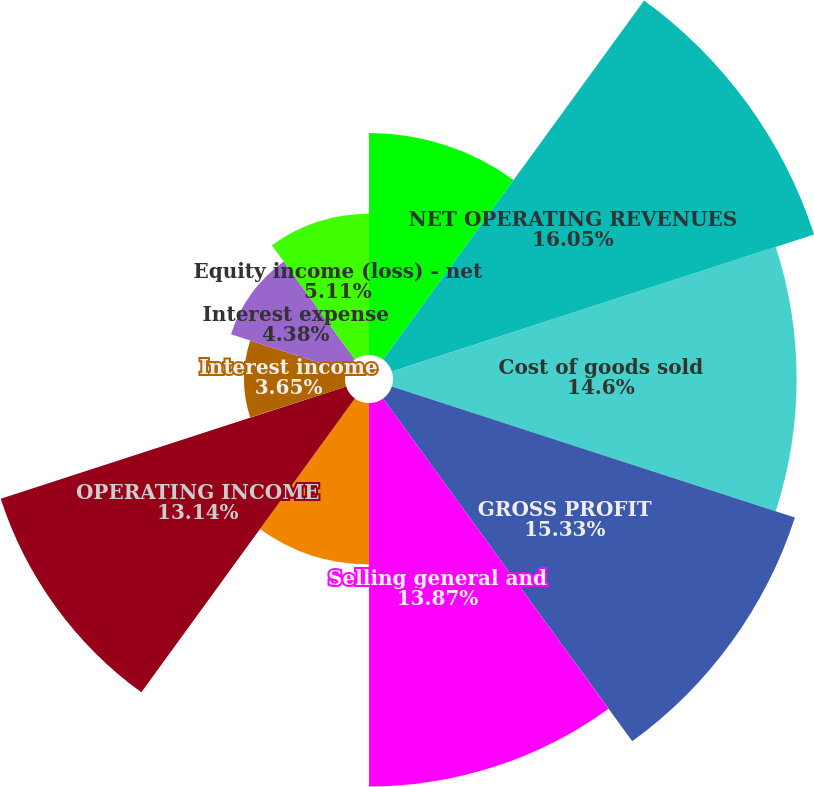Convert chart to OTSL. <chart><loc_0><loc_0><loc_500><loc_500><pie_chart><fcel>Year Ended December 31<fcel>NET OPERATING REVENUES<fcel>Cost of goods sold<fcel>GROSS PROFIT<fcel>Selling general and<fcel>Other operating charges<fcel>OPERATING INCOME<fcel>Interest income<fcel>Interest expense<fcel>Equity income (loss) - net<nl><fcel>8.03%<fcel>16.06%<fcel>14.6%<fcel>15.33%<fcel>13.87%<fcel>5.84%<fcel>13.14%<fcel>3.65%<fcel>4.38%<fcel>5.11%<nl></chart> 